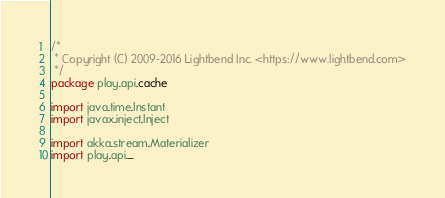<code> <loc_0><loc_0><loc_500><loc_500><_Scala_>/*
 * Copyright (C) 2009-2016 Lightbend Inc. <https://www.lightbend.com>
 */
package play.api.cache

import java.time.Instant
import javax.inject.Inject

import akka.stream.Materializer
import play.api._</code> 